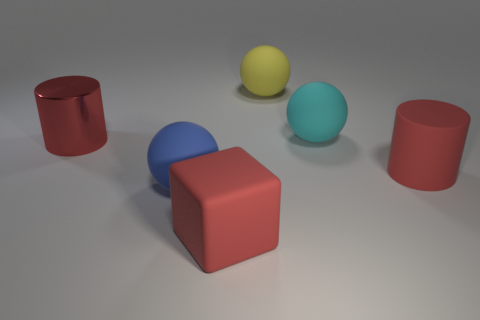There is a large yellow rubber sphere that is behind the rubber cylinder; how many large objects are in front of it?
Your answer should be very brief. 5. Is the color of the matte block on the left side of the big yellow thing the same as the cylinder that is to the left of the block?
Make the answer very short. Yes. What shape is the red thing that is both behind the blue object and to the right of the large blue ball?
Give a very brief answer. Cylinder. Is there another big blue matte object of the same shape as the big blue object?
Keep it short and to the point. No. The metallic object that is the same size as the red matte cube is what shape?
Keep it short and to the point. Cylinder. What material is the big blue sphere?
Your answer should be very brief. Rubber. There is another big cylinder that is the same color as the rubber cylinder; what material is it?
Make the answer very short. Metal. How many shiny things are either big things or big blue objects?
Provide a short and direct response. 1. What is the size of the cube?
Provide a short and direct response. Large. How many objects are big yellow spheres or large rubber things that are on the right side of the big red matte block?
Provide a succinct answer. 3. 